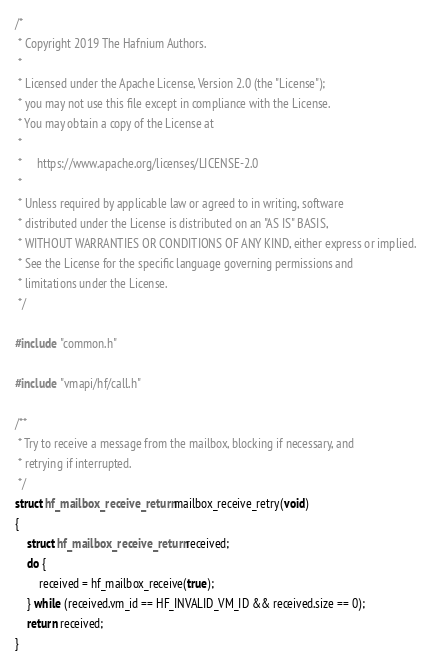Convert code to text. <code><loc_0><loc_0><loc_500><loc_500><_C_>/*
 * Copyright 2019 The Hafnium Authors.
 *
 * Licensed under the Apache License, Version 2.0 (the "License");
 * you may not use this file except in compliance with the License.
 * You may obtain a copy of the License at
 *
 *     https://www.apache.org/licenses/LICENSE-2.0
 *
 * Unless required by applicable law or agreed to in writing, software
 * distributed under the License is distributed on an "AS IS" BASIS,
 * WITHOUT WARRANTIES OR CONDITIONS OF ANY KIND, either express or implied.
 * See the License for the specific language governing permissions and
 * limitations under the License.
 */

#include "common.h"

#include "vmapi/hf/call.h"

/**
 * Try to receive a message from the mailbox, blocking if necessary, and
 * retrying if interrupted.
 */
struct hf_mailbox_receive_return mailbox_receive_retry(void)
{
	struct hf_mailbox_receive_return received;
	do {
		received = hf_mailbox_receive(true);
	} while (received.vm_id == HF_INVALID_VM_ID && received.size == 0);
	return received;
}
</code> 